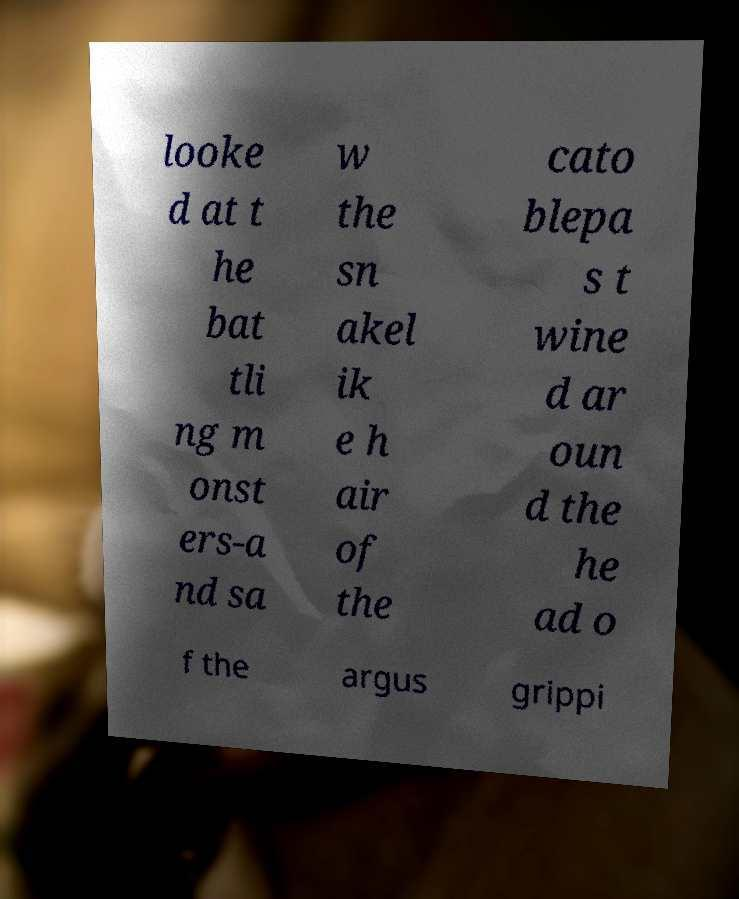What messages or text are displayed in this image? I need them in a readable, typed format. looke d at t he bat tli ng m onst ers-a nd sa w the sn akel ik e h air of the cato blepa s t wine d ar oun d the he ad o f the argus grippi 